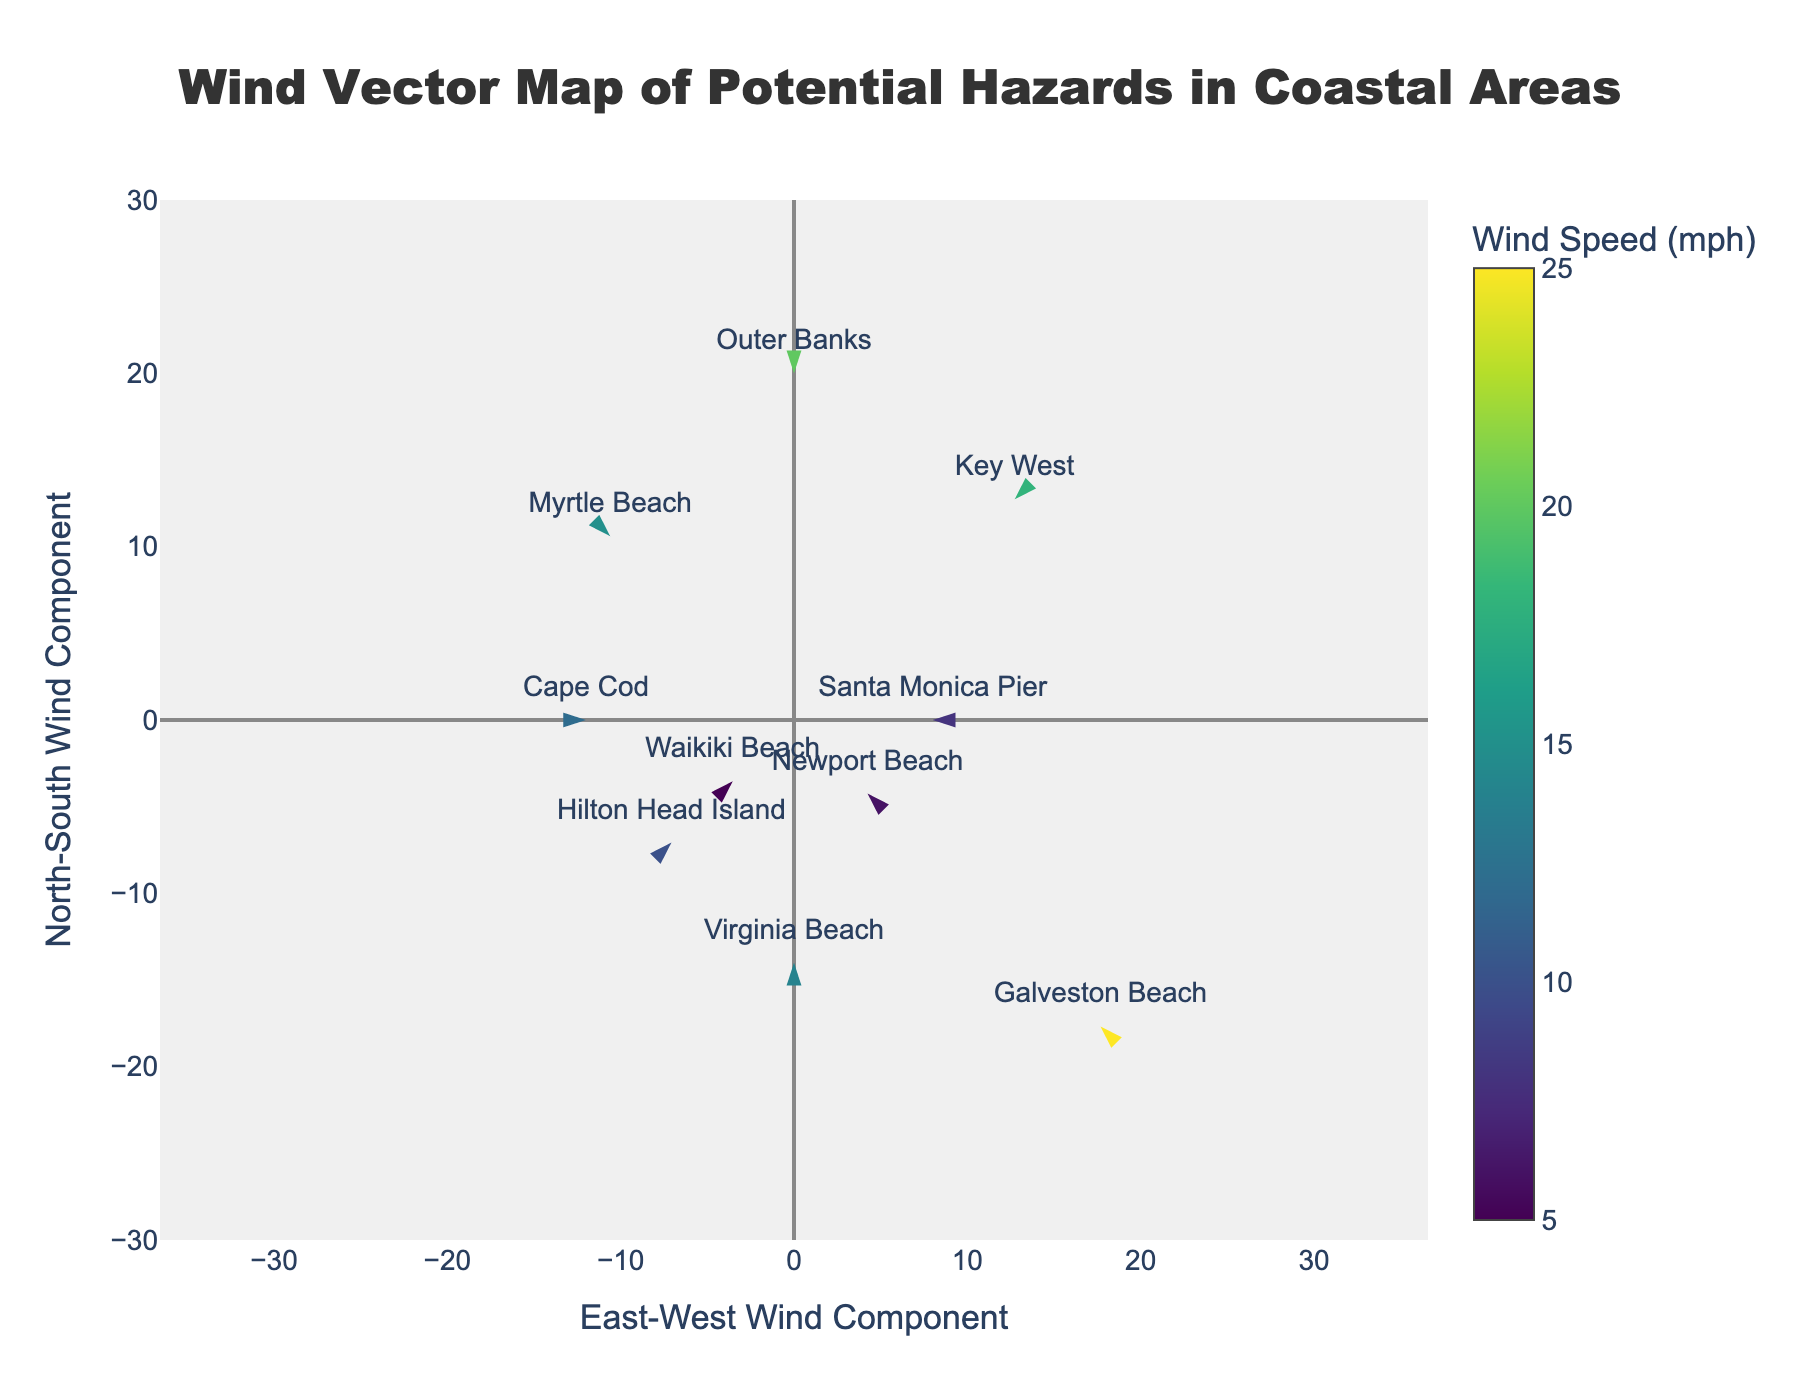Which location has the highest wind speed? By examining the color intensity of the markers, which indicate wind speed, we can identify the location with the highest intensity or refer to the hover information for exact values. Galveston Beach shows the highest wind speed at 25 mph based on the color representation.
Answer: Galveston Beach Which direction is the wind blowing at Virginia Beach? By looking at the direction of the arrow marker and checking the hover information, we see that the wind direction at Virginia Beach is 0 degrees.
Answer: 0 degrees What is the average wind speed of all listed locations? First, note down all wind speeds: 15, 20, 12, 8, 18, 10, 25, 6, 14, 5. Summing these up: 15 + 20 + 12 + 8 + 18 + 10 + 25 + 6 + 14 + 5 = 133. Dividing by the number of locations (10), we get 133 / 10 = 13.3 mph.
Answer: 13.3 mph Which location's wind vector points in the southwest direction (between 180° and 270°)? Checking the hover information for each location or looking at arrow directions on the plot, we see Key West has a wind direction of 225 degrees, which is within the southwest range (180° to 270°).
Answer: Key West Which location has the potential hazard of 'flying umbrellas'? Refer to the hover information associated with each data point, where Hilton Head Island indicates the potential hazard of flying umbrellas.
Answer: Hilton Head Island How many locations have wind directions between 0° and 90°? By examining the wind direction (degrees) for each location in the hover information, we count the locations with directions between 0° and 90°: Cape Cod (90°), Hilton Head Island (45°), and Waikiki Beach (45°). Hence, there are 3 such locations.
Answer: 3 Compare wind speeds between Key West and Santa Monica Pier. Which one is higher? By looking at the hover information or color intensity of the markers, Key West has a wind speed of 18 mph, while Santa Monica Pier has 8 mph. Key West has a higher wind speed.
Answer: Key West Which locations have their wind vectors pointing in the same direction? Studying the hover information for each location, Newport Beach and Galveston Beach both have wind directions of 315 degrees, indicating the same wind vector direction.
Answer: Newport Beach, Galveston Beach What potential hazard is associated with the location having the lowest wind speed? By checking the hover information, the lowest wind speed is 5 mph at Waikiki Beach, which has the potential hazard of a strong undertow.
Answer: Strong undertow Which two locations have the exact same wind direction? Checking the hover information, Hilton Head Island and Waikiki Beach both have wind directions of 45 degrees.
Answer: Hilton Head Island, Waikiki Beach 